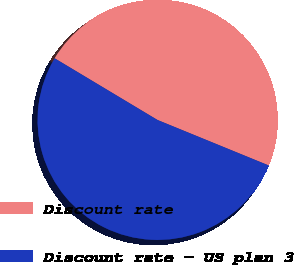Convert chart. <chart><loc_0><loc_0><loc_500><loc_500><pie_chart><fcel>Discount rate<fcel>Discount rate - US plan 3<nl><fcel>47.58%<fcel>52.42%<nl></chart> 